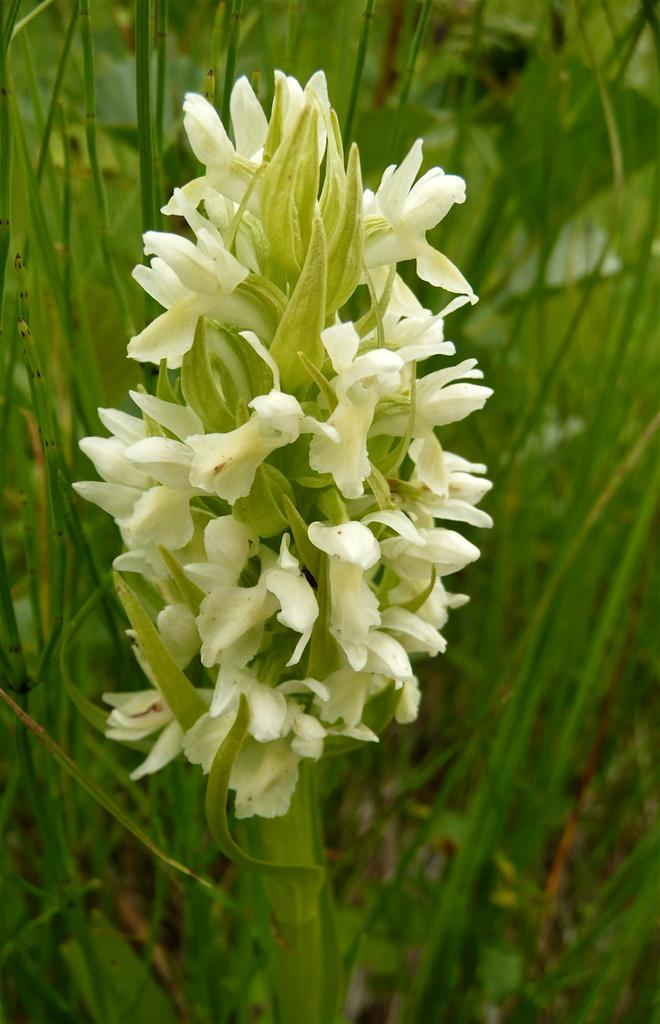What is the main subject of the image? There is a flower in the image. Where is the flower located? The flower is on a plant. What can be seen in the background of the image? There is grass visible in the background of the image. What language is the flower speaking in the image? Flowers do not speak, so there is no language present in the image. 